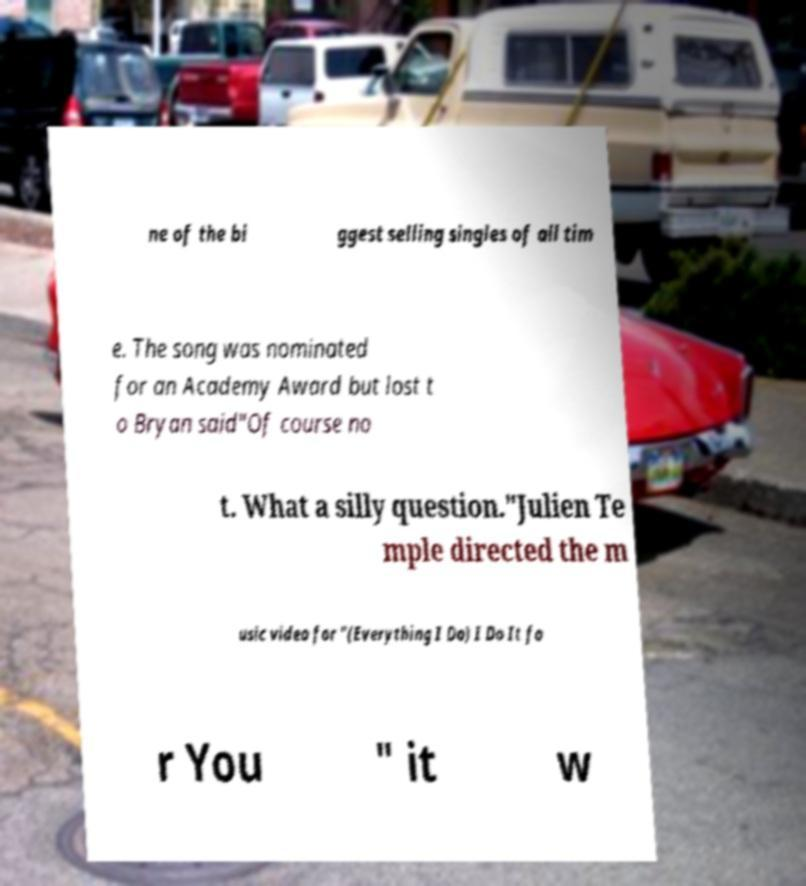Can you accurately transcribe the text from the provided image for me? ne of the bi ggest selling singles of all tim e. The song was nominated for an Academy Award but lost t o Bryan said"Of course no t. What a silly question."Julien Te mple directed the m usic video for "(Everything I Do) I Do It fo r You " it w 